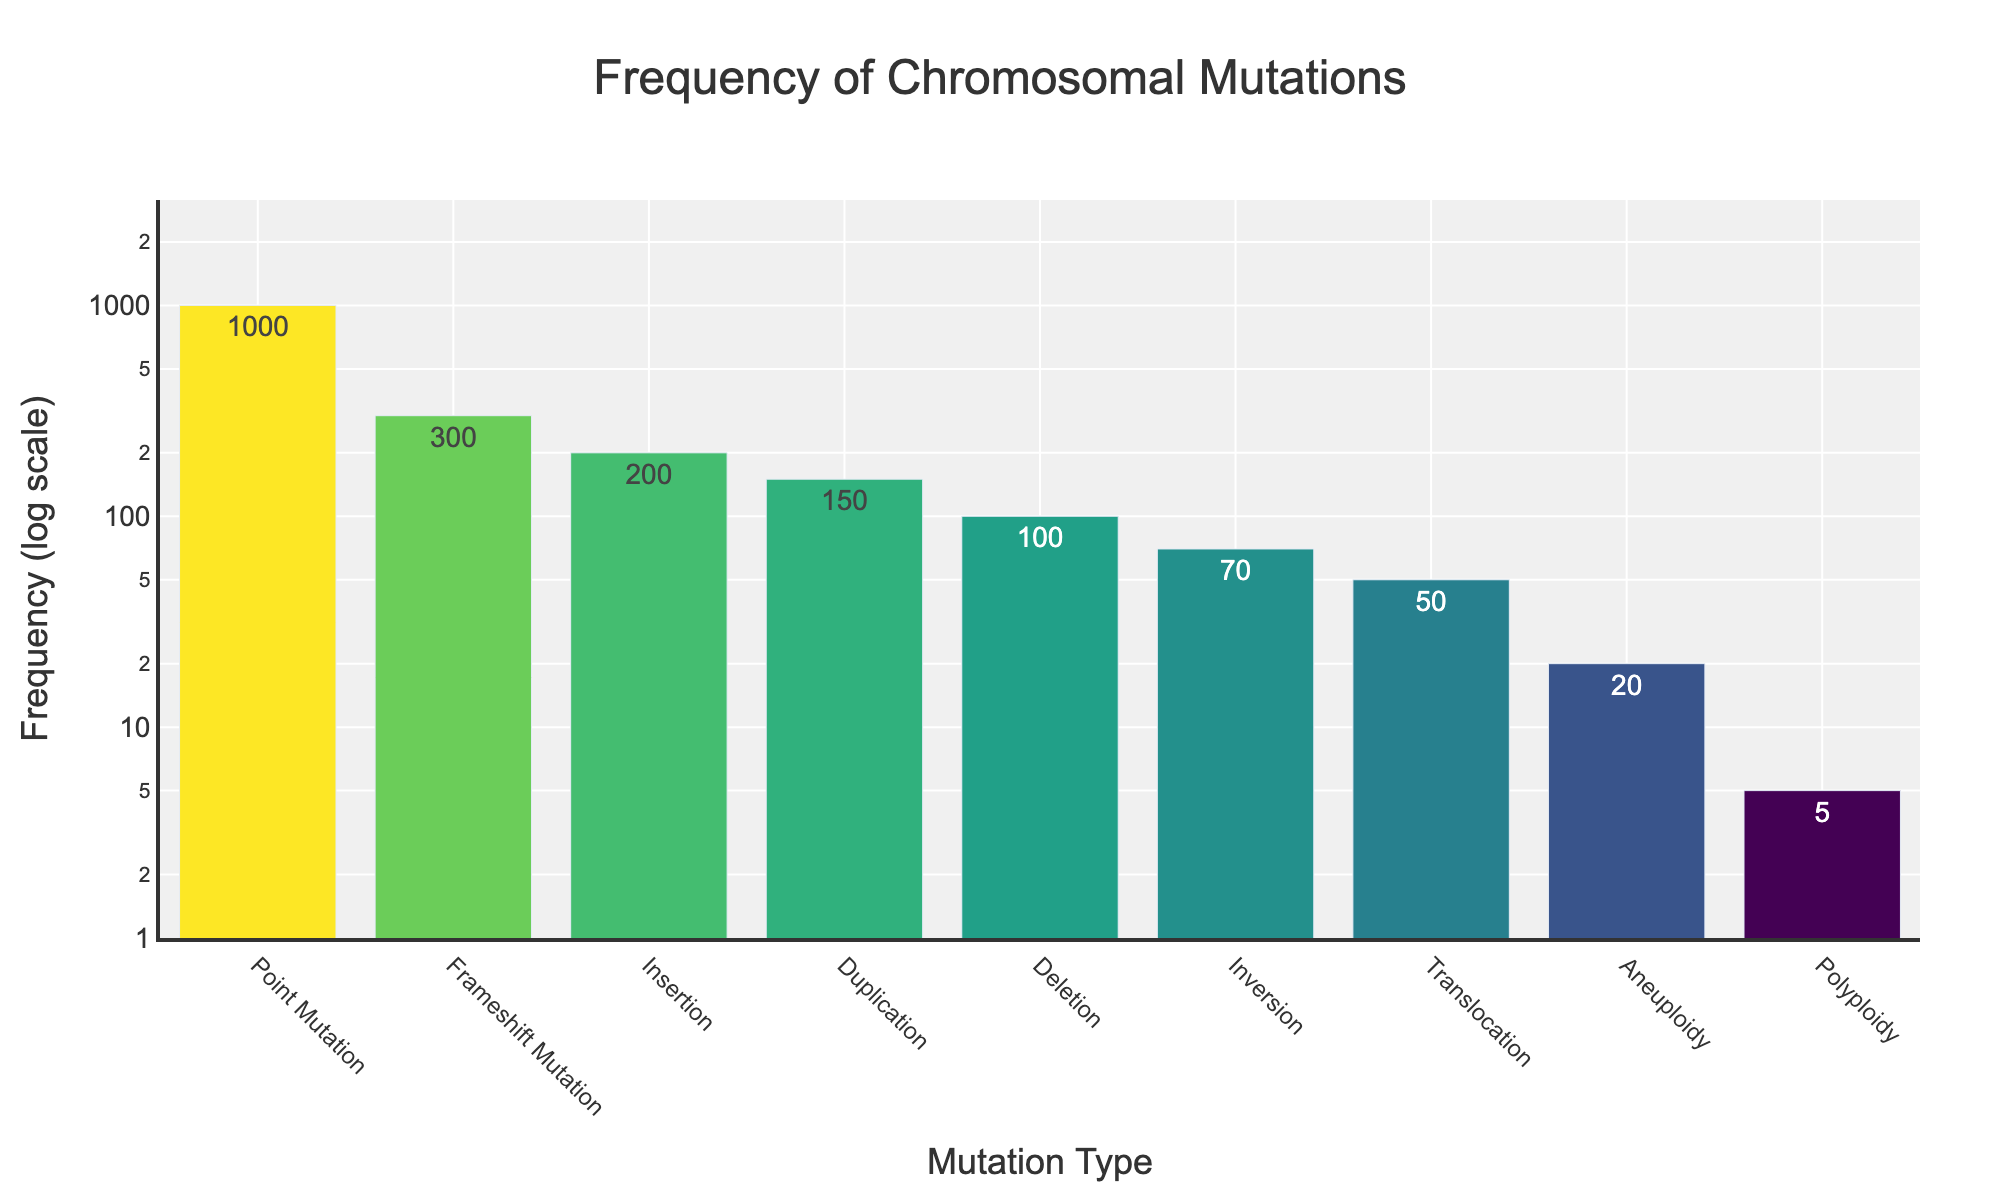What's the title of the plot? The title is usually located at the top of the figure. By observing the top center of the plot, you can see the title "Frequency of Chromosomal Mutations".
Answer: Frequency of Chromosomal Mutations What is the frequency of Point Mutation? The bar labeled "Point Mutation" indicates its frequency. Look at the height of the bar as well as the corresponding text value, which shows "1000".
Answer: 1000 Which chromosomal mutation type has the lowest frequency? The bar with the smallest height and labeled "Polyploidy" represents the lowest frequency. Its corresponding text value is "5".
Answer: Polyploidy How many mutation types have a frequency less than 100? Observing the y-axis with a log scale, look for bars that peak below the 100 mark. The mutation types are Inversion (70), Translocation (50), Aneuploidy (20), and Polyploidy (5), summing to four.
Answer: 4 What is the sum of frequencies for Deletion and Insertion mutations? Locate the bars for "Deletion" and "Insertion" and note their frequencies: 100 for Deletion and 200 for Insertion. Adding these values gives 100 + 200 = 300.
Answer: 300 Which mutation type is twice as frequent as Deletion and what is its frequency? Deletion has a frequency of 100. Doubling this gives 200. The only mutation type with a frequency of 200 is Insertion.
Answer: Insertion Are there more mutations with a frequency above 100 or below 100? Count the bars above the 100 frequency line compared to those below it. Above 100, there are 4 types (Duplication, Point Mutation, Frameshift Mutation, Insertion), and below 100, there are 4 types (Deletion, Inversion, Translocation, Polyploidy).
Answer: Equal How does the frequency of Frameshift Mutation compare to that of Point Mutation? By comparing the heights of the bars, the Frameshift Mutation (300) is significantly lower than Point Mutation (1000).
Answer: Frameshift Mutation is lower What range does the y-axis cover on the plot? Observing the y-axis with a log scale, the range is from approximately 1 (10^0) to slightly above 1000 (10^3).
Answer: 1 to 1000 Which chromosomal mutation has the highest frequency and what is its value? The tallest bar on the plot represents the mutation type with the highest frequency, labeled "Point Mutation", with a frequency value of 1000.
Answer: Point Mutation, 1000 